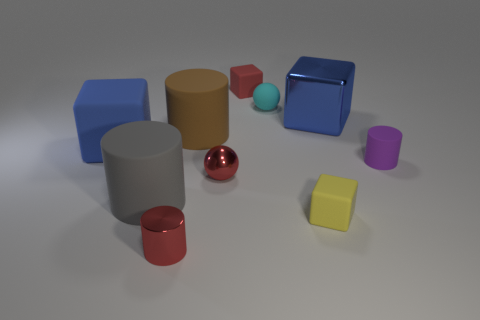Does the large blue thing that is right of the small red sphere have the same shape as the gray thing?
Your answer should be very brief. No. How many large blue things are on the left side of the large metal thing and behind the big blue rubber block?
Make the answer very short. 0. What is the color of the small rubber cube behind the rubber block that is left of the metallic sphere to the left of the small yellow cube?
Ensure brevity in your answer.  Red. There is a small block in front of the purple thing; what number of tiny matte things are behind it?
Keep it short and to the point. 3. What number of other things are the same shape as the big brown thing?
Offer a terse response. 3. How many things are purple blocks or big cubes that are to the right of the red sphere?
Offer a terse response. 1. Are there more balls behind the big brown rubber object than red objects that are to the right of the purple cylinder?
Offer a terse response. Yes. What shape is the red thing that is to the left of the big cylinder on the right side of the tiny red metallic cylinder that is in front of the large rubber block?
Provide a short and direct response. Cylinder. There is a big blue object on the right side of the object that is behind the cyan matte object; what is its shape?
Your answer should be compact. Cube. Is there a red object that has the same material as the large gray cylinder?
Provide a succinct answer. Yes. 